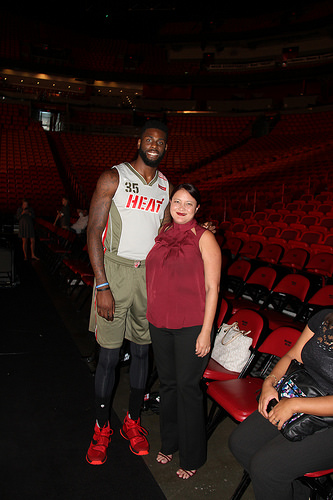<image>
Is there a lady on the chair? No. The lady is not positioned on the chair. They may be near each other, but the lady is not supported by or resting on top of the chair. 